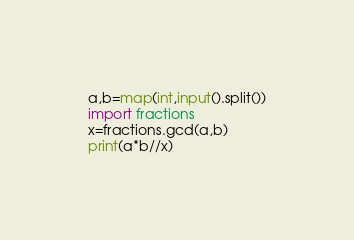Convert code to text. <code><loc_0><loc_0><loc_500><loc_500><_Python_>a,b=map(int,input().split())
import fractions
x=fractions.gcd(a,b)
print(a*b//x)</code> 